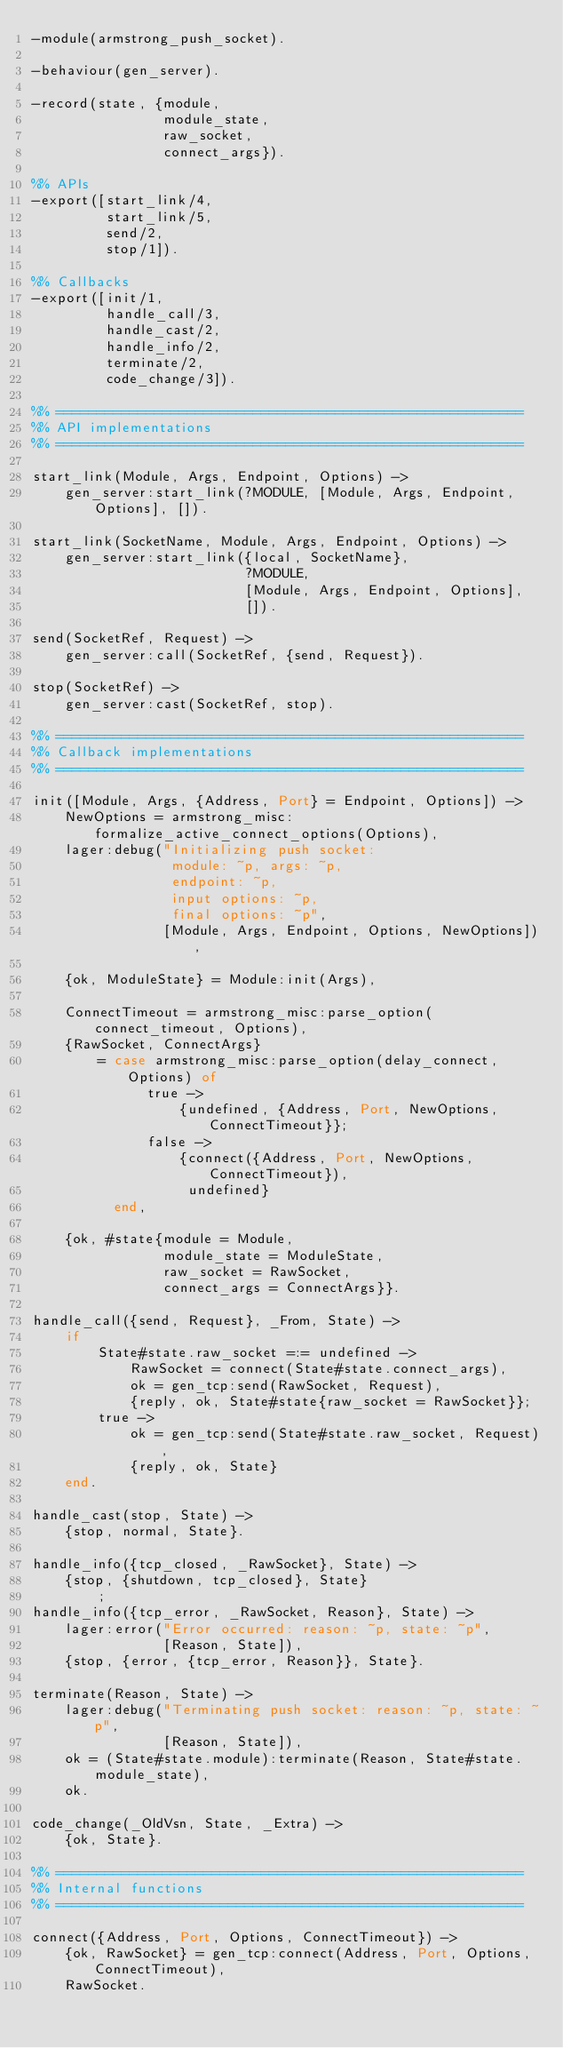<code> <loc_0><loc_0><loc_500><loc_500><_Erlang_>-module(armstrong_push_socket).

-behaviour(gen_server).

-record(state, {module,
                module_state,
                raw_socket,
                connect_args}).

%% APIs
-export([start_link/4,
         start_link/5,
         send/2,
         stop/1]).

%% Callbacks
-export([init/1,
         handle_call/3,
         handle_cast/2,
         handle_info/2,
         terminate/2,
         code_change/3]).

%% =========================================================
%% API implementations
%% =========================================================

start_link(Module, Args, Endpoint, Options) ->
    gen_server:start_link(?MODULE, [Module, Args, Endpoint, Options], []).

start_link(SocketName, Module, Args, Endpoint, Options) ->
    gen_server:start_link({local, SocketName},
                          ?MODULE,
                          [Module, Args, Endpoint, Options],
                          []).

send(SocketRef, Request) ->
    gen_server:call(SocketRef, {send, Request}).

stop(SocketRef) ->
    gen_server:cast(SocketRef, stop).

%% =========================================================
%% Callback implementations
%% =========================================================

init([Module, Args, {Address, Port} = Endpoint, Options]) ->
    NewOptions = armstrong_misc:formalize_active_connect_options(Options),
    lager:debug("Initializing push socket:
                 module: ~p, args: ~p,
                 endpoint: ~p,
                 input options: ~p,
                 final options: ~p",
                [Module, Args, Endpoint, Options, NewOptions]),

    {ok, ModuleState} = Module:init(Args),

    ConnectTimeout = armstrong_misc:parse_option(connect_timeout, Options),
    {RawSocket, ConnectArgs}
        = case armstrong_misc:parse_option(delay_connect, Options) of
              true ->
                  {undefined, {Address, Port, NewOptions, ConnectTimeout}};
              false ->
                  {connect({Address, Port, NewOptions, ConnectTimeout}),
                   undefined}
          end,

    {ok, #state{module = Module,
                module_state = ModuleState,
                raw_socket = RawSocket,
                connect_args = ConnectArgs}}.

handle_call({send, Request}, _From, State) ->
    if
        State#state.raw_socket =:= undefined ->
            RawSocket = connect(State#state.connect_args),
            ok = gen_tcp:send(RawSocket, Request),
            {reply, ok, State#state{raw_socket = RawSocket}};
        true ->
            ok = gen_tcp:send(State#state.raw_socket, Request),
            {reply, ok, State}
    end.

handle_cast(stop, State) ->
    {stop, normal, State}.

handle_info({tcp_closed, _RawSocket}, State) ->
    {stop, {shutdown, tcp_closed}, State}
        ;
handle_info({tcp_error, _RawSocket, Reason}, State) ->
    lager:error("Error occurred: reason: ~p, state: ~p",
                [Reason, State]),
    {stop, {error, {tcp_error, Reason}}, State}.

terminate(Reason, State) ->
    lager:debug("Terminating push socket: reason: ~p, state: ~p",
                [Reason, State]),
    ok = (State#state.module):terminate(Reason, State#state.module_state),
    ok.

code_change(_OldVsn, State, _Extra) ->
    {ok, State}.

%% =========================================================
%% Internal functions
%% =========================================================

connect({Address, Port, Options, ConnectTimeout}) ->
    {ok, RawSocket} = gen_tcp:connect(Address, Port, Options, ConnectTimeout),
    RawSocket.
</code> 